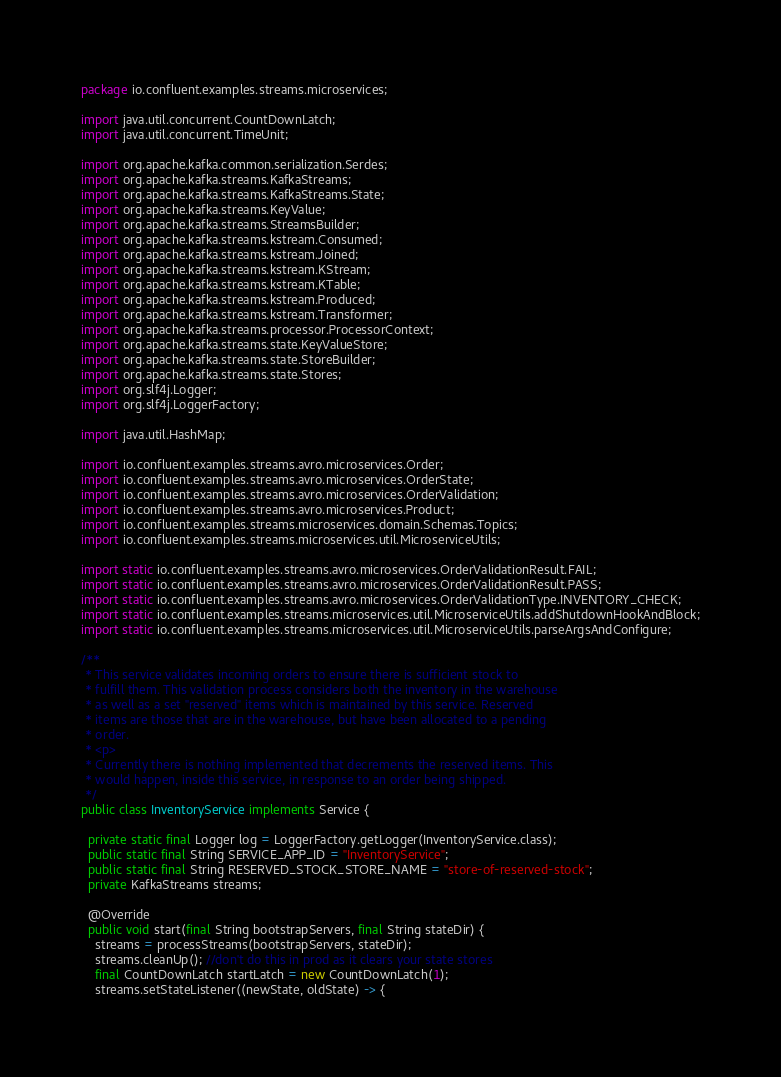<code> <loc_0><loc_0><loc_500><loc_500><_Java_>package io.confluent.examples.streams.microservices;

import java.util.concurrent.CountDownLatch;
import java.util.concurrent.TimeUnit;

import org.apache.kafka.common.serialization.Serdes;
import org.apache.kafka.streams.KafkaStreams;
import org.apache.kafka.streams.KafkaStreams.State;
import org.apache.kafka.streams.KeyValue;
import org.apache.kafka.streams.StreamsBuilder;
import org.apache.kafka.streams.kstream.Consumed;
import org.apache.kafka.streams.kstream.Joined;
import org.apache.kafka.streams.kstream.KStream;
import org.apache.kafka.streams.kstream.KTable;
import org.apache.kafka.streams.kstream.Produced;
import org.apache.kafka.streams.kstream.Transformer;
import org.apache.kafka.streams.processor.ProcessorContext;
import org.apache.kafka.streams.state.KeyValueStore;
import org.apache.kafka.streams.state.StoreBuilder;
import org.apache.kafka.streams.state.Stores;
import org.slf4j.Logger;
import org.slf4j.LoggerFactory;

import java.util.HashMap;

import io.confluent.examples.streams.avro.microservices.Order;
import io.confluent.examples.streams.avro.microservices.OrderState;
import io.confluent.examples.streams.avro.microservices.OrderValidation;
import io.confluent.examples.streams.avro.microservices.Product;
import io.confluent.examples.streams.microservices.domain.Schemas.Topics;
import io.confluent.examples.streams.microservices.util.MicroserviceUtils;

import static io.confluent.examples.streams.avro.microservices.OrderValidationResult.FAIL;
import static io.confluent.examples.streams.avro.microservices.OrderValidationResult.PASS;
import static io.confluent.examples.streams.avro.microservices.OrderValidationType.INVENTORY_CHECK;
import static io.confluent.examples.streams.microservices.util.MicroserviceUtils.addShutdownHookAndBlock;
import static io.confluent.examples.streams.microservices.util.MicroserviceUtils.parseArgsAndConfigure;

/**
 * This service validates incoming orders to ensure there is sufficient stock to
 * fulfill them. This validation process considers both the inventory in the warehouse
 * as well as a set "reserved" items which is maintained by this service. Reserved
 * items are those that are in the warehouse, but have been allocated to a pending
 * order.
 * <p>
 * Currently there is nothing implemented that decrements the reserved items. This
 * would happen, inside this service, in response to an order being shipped.
 */
public class InventoryService implements Service {

  private static final Logger log = LoggerFactory.getLogger(InventoryService.class);
  public static final String SERVICE_APP_ID = "InventoryService";
  public static final String RESERVED_STOCK_STORE_NAME = "store-of-reserved-stock";
  private KafkaStreams streams;

  @Override
  public void start(final String bootstrapServers, final String stateDir) {
    streams = processStreams(bootstrapServers, stateDir);
    streams.cleanUp(); //don't do this in prod as it clears your state stores
    final CountDownLatch startLatch = new CountDownLatch(1);
    streams.setStateListener((newState, oldState) -> {</code> 